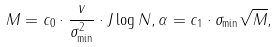<formula> <loc_0><loc_0><loc_500><loc_500>M = c _ { 0 } \cdot \frac { v } { \sigma _ { \min } ^ { 2 } } \cdot J \log N , \alpha = c _ { 1 } \cdot \sigma _ { \min } \sqrt { M } ,</formula> 